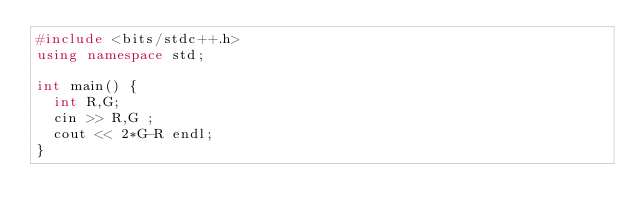<code> <loc_0><loc_0><loc_500><loc_500><_C++_>#include <bits/stdc++.h>
using namespace std;

int main() {
  int R,G;
  cin >> R,G ;
  cout << 2*G-R endl;
}
</code> 